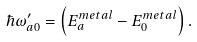Convert formula to latex. <formula><loc_0><loc_0><loc_500><loc_500>\hbar { \omega } ^ { \prime } _ { a 0 } = \left ( E ^ { m e t a l } _ { a } - E ^ { m e t a l } _ { 0 } \right ) .</formula> 